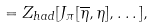Convert formula to latex. <formula><loc_0><loc_0><loc_500><loc_500>\quad = Z _ { h a d } [ J _ { \pi } [ \overline { \eta } , \eta ] , \dots ] ,</formula> 